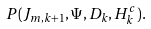Convert formula to latex. <formula><loc_0><loc_0><loc_500><loc_500>P ( J _ { m , k + 1 } , \Psi , D _ { k } , H _ { k } ^ { c } ) .</formula> 